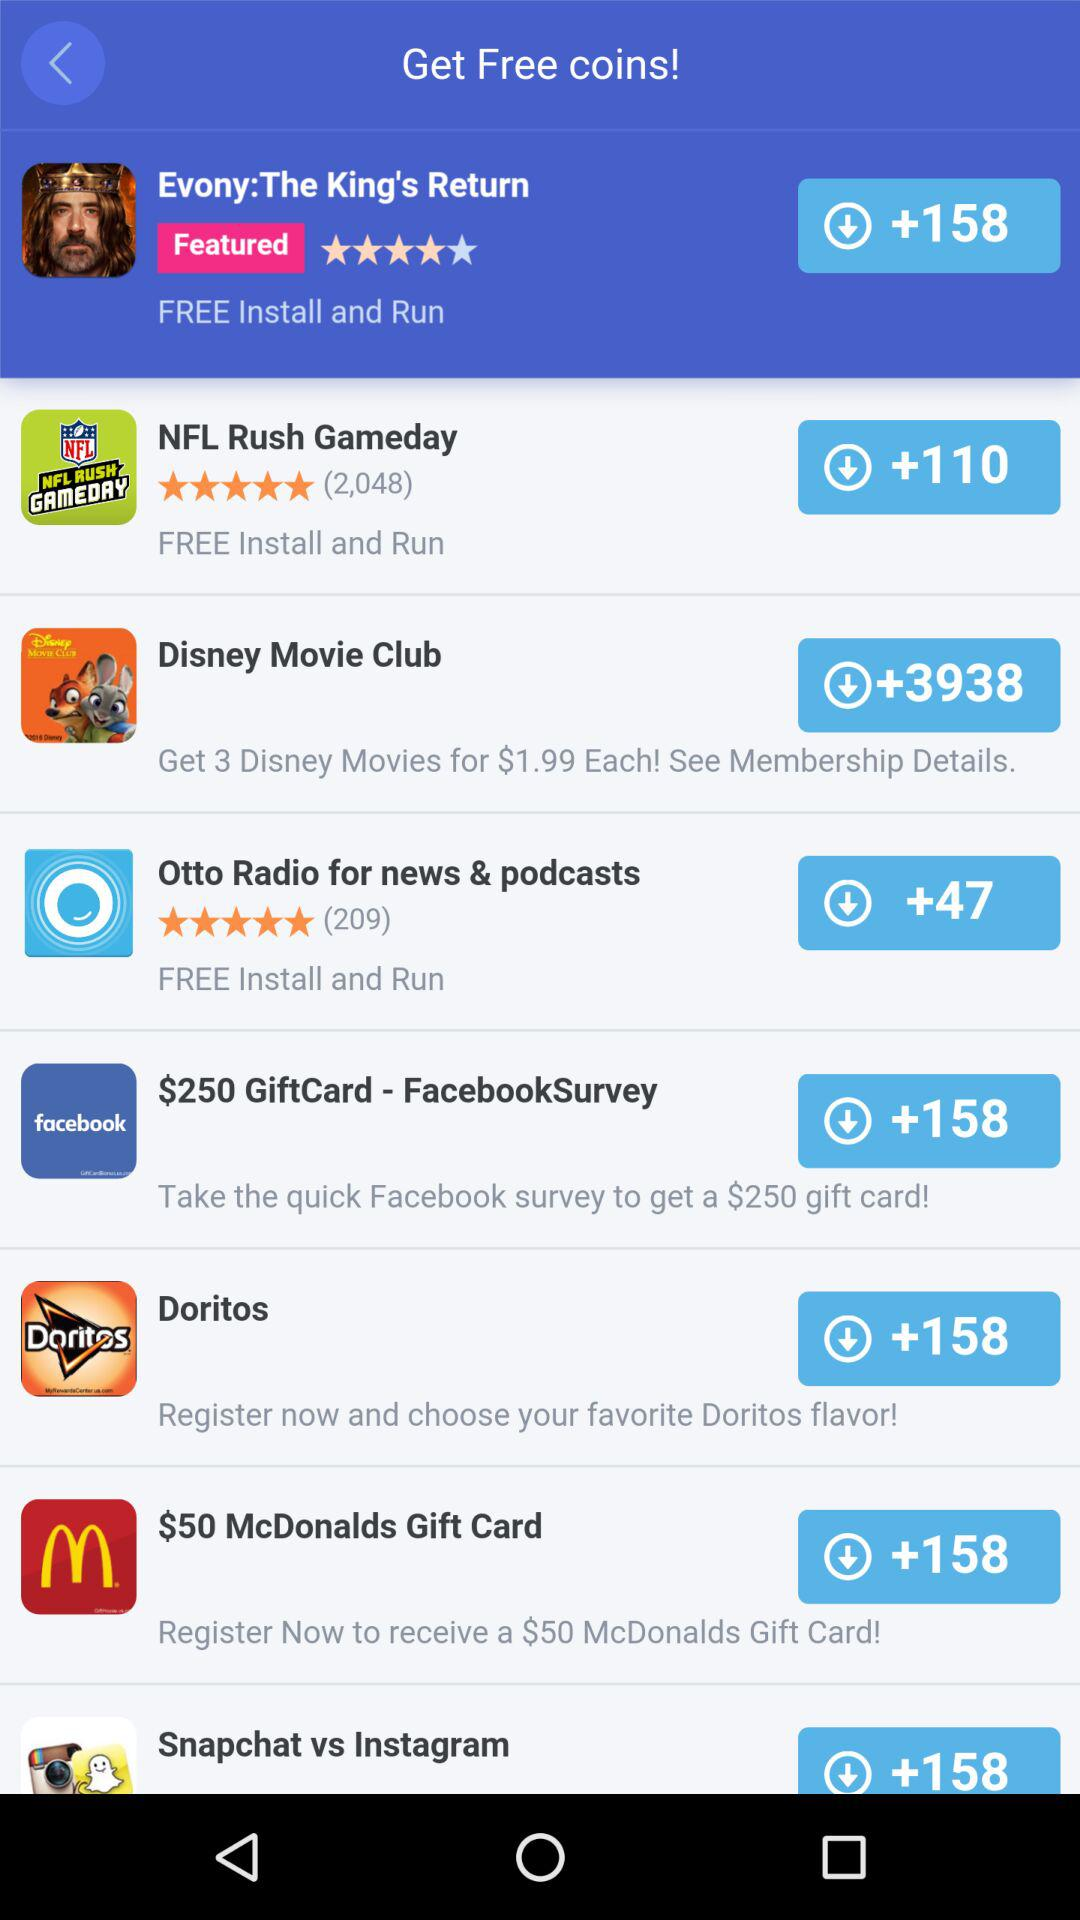What is the value of the "McDonalds" gift card? The value of the "McDonalds" gift card is $50. 